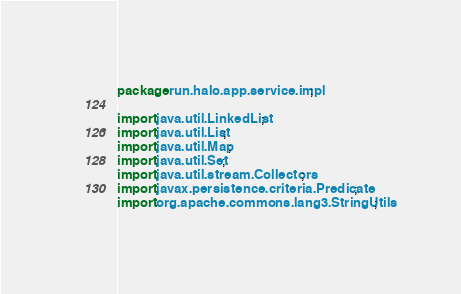<code> <loc_0><loc_0><loc_500><loc_500><_Java_>package run.halo.app.service.impl;

import java.util.LinkedList;
import java.util.List;
import java.util.Map;
import java.util.Set;
import java.util.stream.Collectors;
import javax.persistence.criteria.Predicate;
import org.apache.commons.lang3.StringUtils;</code> 